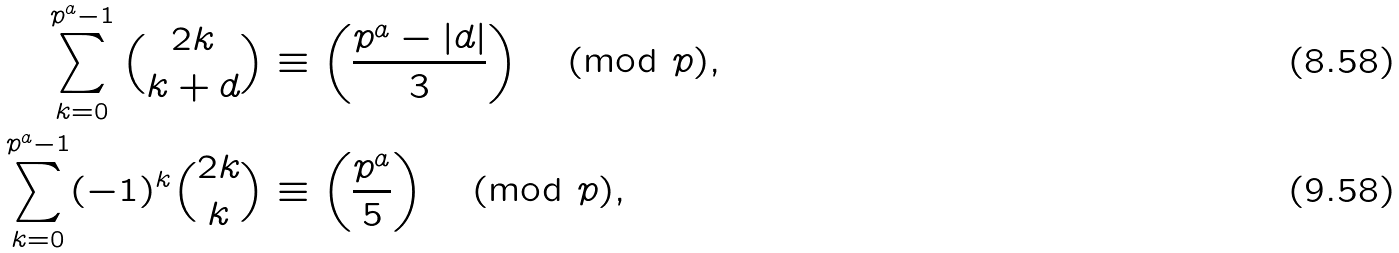<formula> <loc_0><loc_0><loc_500><loc_500>\sum _ { k = 0 } ^ { p ^ { a } - 1 } { 2 k \choose k + d } & \equiv \left ( \frac { p ^ { a } - | d | } { 3 } \right ) \pmod { p } , \\ \sum _ { k = 0 } ^ { p ^ { a } - 1 } ( - 1 ) ^ { k } { 2 k \choose k } & \equiv \left ( \frac { p ^ { a } } { 5 } \right ) \pmod { p } ,</formula> 